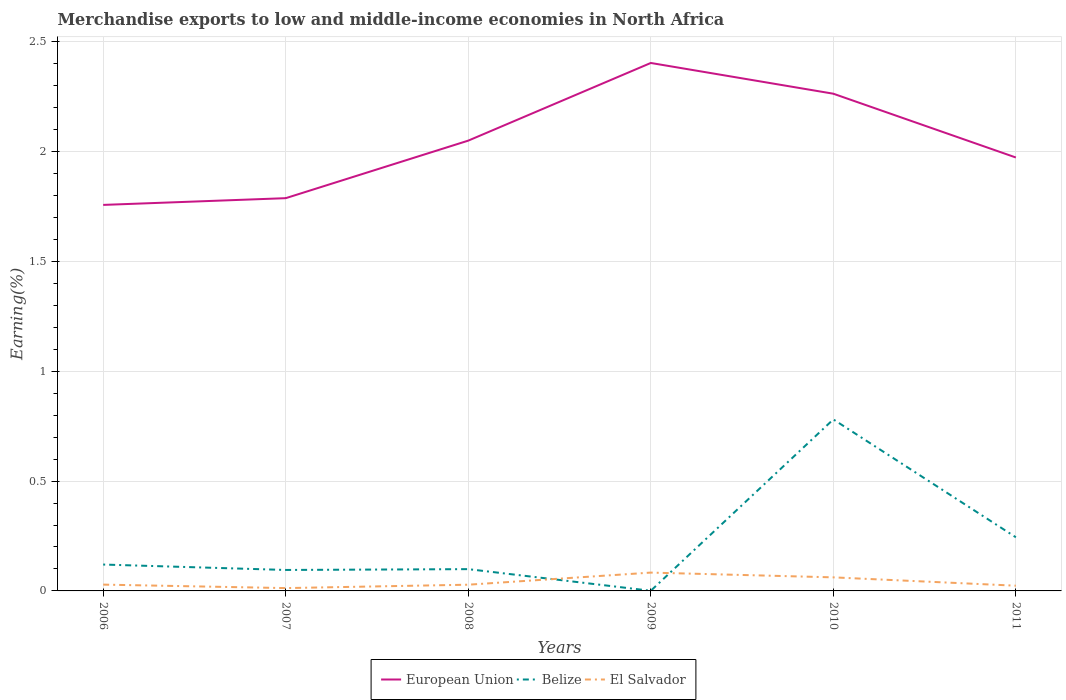Does the line corresponding to El Salvador intersect with the line corresponding to European Union?
Provide a succinct answer. No. Across all years, what is the maximum percentage of amount earned from merchandise exports in Belize?
Your answer should be very brief. 0. In which year was the percentage of amount earned from merchandise exports in European Union maximum?
Your answer should be very brief. 2006. What is the total percentage of amount earned from merchandise exports in El Salvador in the graph?
Offer a very short reply. -0.02. What is the difference between the highest and the second highest percentage of amount earned from merchandise exports in European Union?
Offer a terse response. 0.65. Is the percentage of amount earned from merchandise exports in European Union strictly greater than the percentage of amount earned from merchandise exports in El Salvador over the years?
Your response must be concise. No. How many lines are there?
Keep it short and to the point. 3. How many years are there in the graph?
Ensure brevity in your answer.  6. Does the graph contain any zero values?
Provide a short and direct response. No. Where does the legend appear in the graph?
Your answer should be very brief. Bottom center. How many legend labels are there?
Give a very brief answer. 3. What is the title of the graph?
Your response must be concise. Merchandise exports to low and middle-income economies in North Africa. Does "Nepal" appear as one of the legend labels in the graph?
Provide a succinct answer. No. What is the label or title of the X-axis?
Make the answer very short. Years. What is the label or title of the Y-axis?
Ensure brevity in your answer.  Earning(%). What is the Earning(%) in European Union in 2006?
Your answer should be very brief. 1.76. What is the Earning(%) of Belize in 2006?
Offer a very short reply. 0.12. What is the Earning(%) in El Salvador in 2006?
Provide a succinct answer. 0.03. What is the Earning(%) in European Union in 2007?
Make the answer very short. 1.79. What is the Earning(%) of Belize in 2007?
Your answer should be very brief. 0.1. What is the Earning(%) in El Salvador in 2007?
Make the answer very short. 0.01. What is the Earning(%) of European Union in 2008?
Your answer should be very brief. 2.05. What is the Earning(%) in Belize in 2008?
Make the answer very short. 0.1. What is the Earning(%) in El Salvador in 2008?
Offer a terse response. 0.03. What is the Earning(%) in European Union in 2009?
Keep it short and to the point. 2.4. What is the Earning(%) of Belize in 2009?
Ensure brevity in your answer.  0. What is the Earning(%) in El Salvador in 2009?
Provide a succinct answer. 0.08. What is the Earning(%) of European Union in 2010?
Your answer should be very brief. 2.26. What is the Earning(%) in Belize in 2010?
Ensure brevity in your answer.  0.78. What is the Earning(%) of El Salvador in 2010?
Provide a short and direct response. 0.06. What is the Earning(%) of European Union in 2011?
Your answer should be compact. 1.97. What is the Earning(%) in Belize in 2011?
Offer a terse response. 0.24. What is the Earning(%) in El Salvador in 2011?
Offer a very short reply. 0.02. Across all years, what is the maximum Earning(%) of European Union?
Offer a very short reply. 2.4. Across all years, what is the maximum Earning(%) of Belize?
Provide a succinct answer. 0.78. Across all years, what is the maximum Earning(%) in El Salvador?
Your answer should be very brief. 0.08. Across all years, what is the minimum Earning(%) of European Union?
Offer a terse response. 1.76. Across all years, what is the minimum Earning(%) in Belize?
Ensure brevity in your answer.  0. Across all years, what is the minimum Earning(%) of El Salvador?
Ensure brevity in your answer.  0.01. What is the total Earning(%) of European Union in the graph?
Your response must be concise. 12.23. What is the total Earning(%) in Belize in the graph?
Provide a short and direct response. 1.34. What is the total Earning(%) of El Salvador in the graph?
Offer a very short reply. 0.24. What is the difference between the Earning(%) of European Union in 2006 and that in 2007?
Provide a short and direct response. -0.03. What is the difference between the Earning(%) in Belize in 2006 and that in 2007?
Provide a succinct answer. 0.02. What is the difference between the Earning(%) in El Salvador in 2006 and that in 2007?
Your response must be concise. 0.02. What is the difference between the Earning(%) of European Union in 2006 and that in 2008?
Your response must be concise. -0.29. What is the difference between the Earning(%) of Belize in 2006 and that in 2008?
Your answer should be very brief. 0.02. What is the difference between the Earning(%) in El Salvador in 2006 and that in 2008?
Your response must be concise. 0. What is the difference between the Earning(%) in European Union in 2006 and that in 2009?
Your answer should be very brief. -0.65. What is the difference between the Earning(%) of Belize in 2006 and that in 2009?
Offer a terse response. 0.12. What is the difference between the Earning(%) in El Salvador in 2006 and that in 2009?
Your response must be concise. -0.05. What is the difference between the Earning(%) of European Union in 2006 and that in 2010?
Ensure brevity in your answer.  -0.51. What is the difference between the Earning(%) of Belize in 2006 and that in 2010?
Ensure brevity in your answer.  -0.66. What is the difference between the Earning(%) of El Salvador in 2006 and that in 2010?
Provide a short and direct response. -0.03. What is the difference between the Earning(%) of European Union in 2006 and that in 2011?
Your response must be concise. -0.22. What is the difference between the Earning(%) in Belize in 2006 and that in 2011?
Your answer should be compact. -0.12. What is the difference between the Earning(%) in El Salvador in 2006 and that in 2011?
Keep it short and to the point. 0. What is the difference between the Earning(%) of European Union in 2007 and that in 2008?
Your response must be concise. -0.26. What is the difference between the Earning(%) in Belize in 2007 and that in 2008?
Provide a short and direct response. -0. What is the difference between the Earning(%) of El Salvador in 2007 and that in 2008?
Your answer should be very brief. -0.02. What is the difference between the Earning(%) in European Union in 2007 and that in 2009?
Give a very brief answer. -0.62. What is the difference between the Earning(%) of Belize in 2007 and that in 2009?
Make the answer very short. 0.09. What is the difference between the Earning(%) in El Salvador in 2007 and that in 2009?
Keep it short and to the point. -0.07. What is the difference between the Earning(%) of European Union in 2007 and that in 2010?
Ensure brevity in your answer.  -0.48. What is the difference between the Earning(%) in Belize in 2007 and that in 2010?
Your answer should be compact. -0.69. What is the difference between the Earning(%) in El Salvador in 2007 and that in 2010?
Provide a short and direct response. -0.05. What is the difference between the Earning(%) of European Union in 2007 and that in 2011?
Provide a short and direct response. -0.19. What is the difference between the Earning(%) in Belize in 2007 and that in 2011?
Your response must be concise. -0.15. What is the difference between the Earning(%) of El Salvador in 2007 and that in 2011?
Give a very brief answer. -0.01. What is the difference between the Earning(%) in European Union in 2008 and that in 2009?
Make the answer very short. -0.35. What is the difference between the Earning(%) of Belize in 2008 and that in 2009?
Your response must be concise. 0.1. What is the difference between the Earning(%) in El Salvador in 2008 and that in 2009?
Offer a very short reply. -0.06. What is the difference between the Earning(%) of European Union in 2008 and that in 2010?
Keep it short and to the point. -0.21. What is the difference between the Earning(%) of Belize in 2008 and that in 2010?
Your answer should be compact. -0.68. What is the difference between the Earning(%) of El Salvador in 2008 and that in 2010?
Give a very brief answer. -0.03. What is the difference between the Earning(%) in European Union in 2008 and that in 2011?
Provide a short and direct response. 0.08. What is the difference between the Earning(%) in Belize in 2008 and that in 2011?
Make the answer very short. -0.14. What is the difference between the Earning(%) of El Salvador in 2008 and that in 2011?
Offer a very short reply. 0. What is the difference between the Earning(%) in European Union in 2009 and that in 2010?
Provide a short and direct response. 0.14. What is the difference between the Earning(%) of Belize in 2009 and that in 2010?
Your answer should be compact. -0.78. What is the difference between the Earning(%) of El Salvador in 2009 and that in 2010?
Your answer should be compact. 0.02. What is the difference between the Earning(%) in European Union in 2009 and that in 2011?
Ensure brevity in your answer.  0.43. What is the difference between the Earning(%) in Belize in 2009 and that in 2011?
Keep it short and to the point. -0.24. What is the difference between the Earning(%) of El Salvador in 2009 and that in 2011?
Your answer should be very brief. 0.06. What is the difference between the Earning(%) of European Union in 2010 and that in 2011?
Give a very brief answer. 0.29. What is the difference between the Earning(%) in Belize in 2010 and that in 2011?
Your response must be concise. 0.54. What is the difference between the Earning(%) of El Salvador in 2010 and that in 2011?
Your answer should be very brief. 0.04. What is the difference between the Earning(%) of European Union in 2006 and the Earning(%) of Belize in 2007?
Provide a succinct answer. 1.66. What is the difference between the Earning(%) in European Union in 2006 and the Earning(%) in El Salvador in 2007?
Your response must be concise. 1.74. What is the difference between the Earning(%) of Belize in 2006 and the Earning(%) of El Salvador in 2007?
Provide a short and direct response. 0.11. What is the difference between the Earning(%) of European Union in 2006 and the Earning(%) of Belize in 2008?
Give a very brief answer. 1.66. What is the difference between the Earning(%) in European Union in 2006 and the Earning(%) in El Salvador in 2008?
Provide a short and direct response. 1.73. What is the difference between the Earning(%) of Belize in 2006 and the Earning(%) of El Salvador in 2008?
Your answer should be compact. 0.09. What is the difference between the Earning(%) of European Union in 2006 and the Earning(%) of Belize in 2009?
Ensure brevity in your answer.  1.76. What is the difference between the Earning(%) of European Union in 2006 and the Earning(%) of El Salvador in 2009?
Your answer should be very brief. 1.67. What is the difference between the Earning(%) in Belize in 2006 and the Earning(%) in El Salvador in 2009?
Keep it short and to the point. 0.04. What is the difference between the Earning(%) of European Union in 2006 and the Earning(%) of Belize in 2010?
Make the answer very short. 0.98. What is the difference between the Earning(%) of European Union in 2006 and the Earning(%) of El Salvador in 2010?
Offer a terse response. 1.7. What is the difference between the Earning(%) in Belize in 2006 and the Earning(%) in El Salvador in 2010?
Offer a terse response. 0.06. What is the difference between the Earning(%) in European Union in 2006 and the Earning(%) in Belize in 2011?
Your answer should be compact. 1.51. What is the difference between the Earning(%) in European Union in 2006 and the Earning(%) in El Salvador in 2011?
Provide a succinct answer. 1.73. What is the difference between the Earning(%) in Belize in 2006 and the Earning(%) in El Salvador in 2011?
Provide a short and direct response. 0.1. What is the difference between the Earning(%) in European Union in 2007 and the Earning(%) in Belize in 2008?
Ensure brevity in your answer.  1.69. What is the difference between the Earning(%) of European Union in 2007 and the Earning(%) of El Salvador in 2008?
Your response must be concise. 1.76. What is the difference between the Earning(%) in Belize in 2007 and the Earning(%) in El Salvador in 2008?
Ensure brevity in your answer.  0.07. What is the difference between the Earning(%) in European Union in 2007 and the Earning(%) in Belize in 2009?
Provide a succinct answer. 1.79. What is the difference between the Earning(%) in European Union in 2007 and the Earning(%) in El Salvador in 2009?
Ensure brevity in your answer.  1.7. What is the difference between the Earning(%) in Belize in 2007 and the Earning(%) in El Salvador in 2009?
Offer a very short reply. 0.01. What is the difference between the Earning(%) of European Union in 2007 and the Earning(%) of El Salvador in 2010?
Give a very brief answer. 1.73. What is the difference between the Earning(%) of Belize in 2007 and the Earning(%) of El Salvador in 2010?
Offer a very short reply. 0.03. What is the difference between the Earning(%) of European Union in 2007 and the Earning(%) of Belize in 2011?
Provide a short and direct response. 1.54. What is the difference between the Earning(%) of European Union in 2007 and the Earning(%) of El Salvador in 2011?
Offer a very short reply. 1.76. What is the difference between the Earning(%) in Belize in 2007 and the Earning(%) in El Salvador in 2011?
Keep it short and to the point. 0.07. What is the difference between the Earning(%) of European Union in 2008 and the Earning(%) of Belize in 2009?
Offer a terse response. 2.05. What is the difference between the Earning(%) of European Union in 2008 and the Earning(%) of El Salvador in 2009?
Offer a very short reply. 1.97. What is the difference between the Earning(%) of Belize in 2008 and the Earning(%) of El Salvador in 2009?
Make the answer very short. 0.02. What is the difference between the Earning(%) in European Union in 2008 and the Earning(%) in Belize in 2010?
Offer a terse response. 1.27. What is the difference between the Earning(%) in European Union in 2008 and the Earning(%) in El Salvador in 2010?
Make the answer very short. 1.99. What is the difference between the Earning(%) in Belize in 2008 and the Earning(%) in El Salvador in 2010?
Ensure brevity in your answer.  0.04. What is the difference between the Earning(%) of European Union in 2008 and the Earning(%) of Belize in 2011?
Offer a very short reply. 1.81. What is the difference between the Earning(%) in European Union in 2008 and the Earning(%) in El Salvador in 2011?
Make the answer very short. 2.03. What is the difference between the Earning(%) of Belize in 2008 and the Earning(%) of El Salvador in 2011?
Give a very brief answer. 0.08. What is the difference between the Earning(%) in European Union in 2009 and the Earning(%) in Belize in 2010?
Your answer should be very brief. 1.62. What is the difference between the Earning(%) of European Union in 2009 and the Earning(%) of El Salvador in 2010?
Your response must be concise. 2.34. What is the difference between the Earning(%) of Belize in 2009 and the Earning(%) of El Salvador in 2010?
Keep it short and to the point. -0.06. What is the difference between the Earning(%) of European Union in 2009 and the Earning(%) of Belize in 2011?
Keep it short and to the point. 2.16. What is the difference between the Earning(%) of European Union in 2009 and the Earning(%) of El Salvador in 2011?
Make the answer very short. 2.38. What is the difference between the Earning(%) in Belize in 2009 and the Earning(%) in El Salvador in 2011?
Make the answer very short. -0.02. What is the difference between the Earning(%) of European Union in 2010 and the Earning(%) of Belize in 2011?
Give a very brief answer. 2.02. What is the difference between the Earning(%) of European Union in 2010 and the Earning(%) of El Salvador in 2011?
Ensure brevity in your answer.  2.24. What is the difference between the Earning(%) in Belize in 2010 and the Earning(%) in El Salvador in 2011?
Your answer should be very brief. 0.76. What is the average Earning(%) of European Union per year?
Offer a terse response. 2.04. What is the average Earning(%) of Belize per year?
Make the answer very short. 0.22. What is the average Earning(%) of El Salvador per year?
Your response must be concise. 0.04. In the year 2006, what is the difference between the Earning(%) in European Union and Earning(%) in Belize?
Make the answer very short. 1.64. In the year 2006, what is the difference between the Earning(%) in European Union and Earning(%) in El Salvador?
Your response must be concise. 1.73. In the year 2006, what is the difference between the Earning(%) of Belize and Earning(%) of El Salvador?
Ensure brevity in your answer.  0.09. In the year 2007, what is the difference between the Earning(%) of European Union and Earning(%) of Belize?
Your answer should be compact. 1.69. In the year 2007, what is the difference between the Earning(%) in European Union and Earning(%) in El Salvador?
Offer a terse response. 1.77. In the year 2007, what is the difference between the Earning(%) in Belize and Earning(%) in El Salvador?
Provide a succinct answer. 0.08. In the year 2008, what is the difference between the Earning(%) in European Union and Earning(%) in Belize?
Keep it short and to the point. 1.95. In the year 2008, what is the difference between the Earning(%) in European Union and Earning(%) in El Salvador?
Provide a succinct answer. 2.02. In the year 2008, what is the difference between the Earning(%) of Belize and Earning(%) of El Salvador?
Your answer should be very brief. 0.07. In the year 2009, what is the difference between the Earning(%) in European Union and Earning(%) in Belize?
Offer a very short reply. 2.4. In the year 2009, what is the difference between the Earning(%) in European Union and Earning(%) in El Salvador?
Provide a succinct answer. 2.32. In the year 2009, what is the difference between the Earning(%) in Belize and Earning(%) in El Salvador?
Give a very brief answer. -0.08. In the year 2010, what is the difference between the Earning(%) of European Union and Earning(%) of Belize?
Your answer should be very brief. 1.48. In the year 2010, what is the difference between the Earning(%) in European Union and Earning(%) in El Salvador?
Provide a short and direct response. 2.2. In the year 2010, what is the difference between the Earning(%) of Belize and Earning(%) of El Salvador?
Your response must be concise. 0.72. In the year 2011, what is the difference between the Earning(%) of European Union and Earning(%) of Belize?
Your response must be concise. 1.73. In the year 2011, what is the difference between the Earning(%) in European Union and Earning(%) in El Salvador?
Your answer should be compact. 1.95. In the year 2011, what is the difference between the Earning(%) of Belize and Earning(%) of El Salvador?
Your answer should be very brief. 0.22. What is the ratio of the Earning(%) of European Union in 2006 to that in 2007?
Offer a terse response. 0.98. What is the ratio of the Earning(%) of Belize in 2006 to that in 2007?
Ensure brevity in your answer.  1.26. What is the ratio of the Earning(%) of El Salvador in 2006 to that in 2007?
Make the answer very short. 2.23. What is the ratio of the Earning(%) of European Union in 2006 to that in 2008?
Your answer should be very brief. 0.86. What is the ratio of the Earning(%) of Belize in 2006 to that in 2008?
Your answer should be compact. 1.21. What is the ratio of the Earning(%) of El Salvador in 2006 to that in 2008?
Provide a succinct answer. 1.01. What is the ratio of the Earning(%) in European Union in 2006 to that in 2009?
Your response must be concise. 0.73. What is the ratio of the Earning(%) of Belize in 2006 to that in 2009?
Offer a terse response. 175.29. What is the ratio of the Earning(%) of El Salvador in 2006 to that in 2009?
Provide a succinct answer. 0.34. What is the ratio of the Earning(%) of European Union in 2006 to that in 2010?
Provide a succinct answer. 0.78. What is the ratio of the Earning(%) of Belize in 2006 to that in 2010?
Make the answer very short. 0.15. What is the ratio of the Earning(%) of El Salvador in 2006 to that in 2010?
Keep it short and to the point. 0.46. What is the ratio of the Earning(%) of European Union in 2006 to that in 2011?
Ensure brevity in your answer.  0.89. What is the ratio of the Earning(%) of Belize in 2006 to that in 2011?
Provide a succinct answer. 0.49. What is the ratio of the Earning(%) in El Salvador in 2006 to that in 2011?
Your answer should be compact. 1.21. What is the ratio of the Earning(%) of European Union in 2007 to that in 2008?
Offer a terse response. 0.87. What is the ratio of the Earning(%) of Belize in 2007 to that in 2008?
Your response must be concise. 0.96. What is the ratio of the Earning(%) in El Salvador in 2007 to that in 2008?
Your response must be concise. 0.45. What is the ratio of the Earning(%) in European Union in 2007 to that in 2009?
Your answer should be very brief. 0.74. What is the ratio of the Earning(%) in Belize in 2007 to that in 2009?
Keep it short and to the point. 139.32. What is the ratio of the Earning(%) in El Salvador in 2007 to that in 2009?
Provide a short and direct response. 0.15. What is the ratio of the Earning(%) of European Union in 2007 to that in 2010?
Provide a short and direct response. 0.79. What is the ratio of the Earning(%) of Belize in 2007 to that in 2010?
Give a very brief answer. 0.12. What is the ratio of the Earning(%) of El Salvador in 2007 to that in 2010?
Give a very brief answer. 0.21. What is the ratio of the Earning(%) in European Union in 2007 to that in 2011?
Make the answer very short. 0.91. What is the ratio of the Earning(%) in Belize in 2007 to that in 2011?
Offer a very short reply. 0.39. What is the ratio of the Earning(%) of El Salvador in 2007 to that in 2011?
Your answer should be compact. 0.54. What is the ratio of the Earning(%) in European Union in 2008 to that in 2009?
Your answer should be very brief. 0.85. What is the ratio of the Earning(%) of Belize in 2008 to that in 2009?
Provide a succinct answer. 144.79. What is the ratio of the Earning(%) of El Salvador in 2008 to that in 2009?
Offer a terse response. 0.34. What is the ratio of the Earning(%) of European Union in 2008 to that in 2010?
Offer a very short reply. 0.91. What is the ratio of the Earning(%) in Belize in 2008 to that in 2010?
Offer a very short reply. 0.13. What is the ratio of the Earning(%) in El Salvador in 2008 to that in 2010?
Keep it short and to the point. 0.46. What is the ratio of the Earning(%) of European Union in 2008 to that in 2011?
Your answer should be very brief. 1.04. What is the ratio of the Earning(%) of Belize in 2008 to that in 2011?
Make the answer very short. 0.41. What is the ratio of the Earning(%) in El Salvador in 2008 to that in 2011?
Make the answer very short. 1.19. What is the ratio of the Earning(%) of European Union in 2009 to that in 2010?
Offer a terse response. 1.06. What is the ratio of the Earning(%) in Belize in 2009 to that in 2010?
Offer a very short reply. 0. What is the ratio of the Earning(%) in El Salvador in 2009 to that in 2010?
Your answer should be very brief. 1.35. What is the ratio of the Earning(%) in European Union in 2009 to that in 2011?
Offer a very short reply. 1.22. What is the ratio of the Earning(%) of Belize in 2009 to that in 2011?
Offer a very short reply. 0. What is the ratio of the Earning(%) in El Salvador in 2009 to that in 2011?
Your answer should be very brief. 3.51. What is the ratio of the Earning(%) in European Union in 2010 to that in 2011?
Your response must be concise. 1.15. What is the ratio of the Earning(%) of Belize in 2010 to that in 2011?
Make the answer very short. 3.2. What is the ratio of the Earning(%) in El Salvador in 2010 to that in 2011?
Your answer should be compact. 2.6. What is the difference between the highest and the second highest Earning(%) of European Union?
Offer a terse response. 0.14. What is the difference between the highest and the second highest Earning(%) in Belize?
Ensure brevity in your answer.  0.54. What is the difference between the highest and the second highest Earning(%) of El Salvador?
Give a very brief answer. 0.02. What is the difference between the highest and the lowest Earning(%) in European Union?
Ensure brevity in your answer.  0.65. What is the difference between the highest and the lowest Earning(%) in Belize?
Your answer should be very brief. 0.78. What is the difference between the highest and the lowest Earning(%) of El Salvador?
Give a very brief answer. 0.07. 